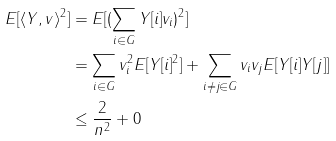<formula> <loc_0><loc_0><loc_500><loc_500>E [ \langle Y , v \rangle ^ { 2 } ] & = E [ ( \sum _ { i \in G } Y [ i ] v _ { i } ) ^ { 2 } ] \\ & = \sum _ { i \in G } v _ { i } ^ { 2 } E [ Y [ i ] ^ { 2 } ] + \sum _ { i \neq j \in G } v _ { i } v _ { j } E [ Y [ i ] Y [ j ] ] \\ & \leq \frac { 2 } { n ^ { 2 } } + 0 \\</formula> 